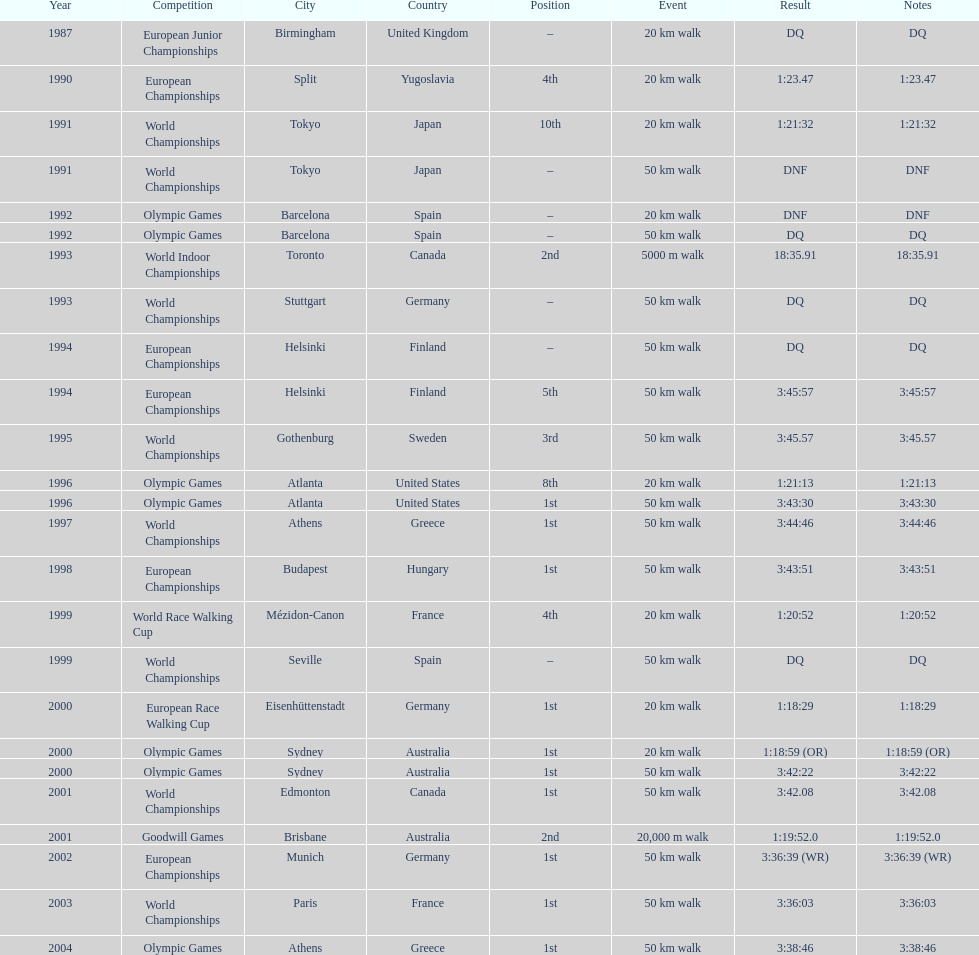How many times did korzeniowski finish above fourth place? 13. I'm looking to parse the entire table for insights. Could you assist me with that? {'header': ['Year', 'Competition', 'City', 'Country', 'Position', 'Event', 'Result', 'Notes'], 'rows': [['1987', 'European Junior Championships', 'Birmingham', 'United Kingdom', '–', '20\xa0km walk', 'DQ', 'DQ'], ['1990', 'European Championships', 'Split', 'Yugoslavia', '4th', '20\xa0km walk', '1:23.47', '1:23.47'], ['1991', 'World Championships', 'Tokyo', 'Japan', '10th', '20\xa0km walk', '1:21:32', '1:21:32'], ['1991', 'World Championships', 'Tokyo', 'Japan', '–', '50\xa0km walk', 'DNF', 'DNF'], ['1992', 'Olympic Games', 'Barcelona', 'Spain', '–', '20\xa0km walk', 'DNF', 'DNF'], ['1992', 'Olympic Games', 'Barcelona', 'Spain', '–', '50\xa0km walk', 'DQ', 'DQ'], ['1993', 'World Indoor Championships', 'Toronto', 'Canada', '2nd', '5000 m walk', '18:35.91', '18:35.91'], ['1993', 'World Championships', 'Stuttgart', 'Germany', '–', '50\xa0km walk', 'DQ', 'DQ'], ['1994', 'European Championships', 'Helsinki', 'Finland', '–', '50\xa0km walk', 'DQ', 'DQ'], ['1994', 'European Championships', 'Helsinki', 'Finland', '5th', '50\xa0km walk', '3:45:57', '3:45:57'], ['1995', 'World Championships', 'Gothenburg', 'Sweden', '3rd', '50\xa0km walk', '3:45.57', '3:45.57'], ['1996', 'Olympic Games', 'Atlanta', 'United States', '8th', '20\xa0km walk', '1:21:13', '1:21:13'], ['1996', 'Olympic Games', 'Atlanta', 'United States', '1st', '50\xa0km walk', '3:43:30', '3:43:30'], ['1997', 'World Championships', 'Athens', 'Greece', '1st', '50\xa0km walk', '3:44:46', '3:44:46'], ['1998', 'European Championships', 'Budapest', 'Hungary', '1st', '50\xa0km walk', '3:43:51', '3:43:51'], ['1999', 'World Race Walking Cup', 'Mézidon-Canon', 'France', '4th', '20\xa0km walk', '1:20:52', '1:20:52'], ['1999', 'World Championships', 'Seville', 'Spain', '–', '50\xa0km walk', 'DQ', 'DQ'], ['2000', 'European Race Walking Cup', 'Eisenhüttenstadt', 'Germany', '1st', '20\xa0km walk', '1:18:29', '1:18:29'], ['2000', 'Olympic Games', 'Sydney', 'Australia', '1st', '20\xa0km walk', '1:18:59 (OR)', '1:18:59 (OR)'], ['2000', 'Olympic Games', 'Sydney', 'Australia', '1st', '50\xa0km walk', '3:42:22', '3:42:22'], ['2001', 'World Championships', 'Edmonton', 'Canada', '1st', '50\xa0km walk', '3:42.08', '3:42.08'], ['2001', 'Goodwill Games', 'Brisbane', 'Australia', '2nd', '20,000 m walk', '1:19:52.0', '1:19:52.0'], ['2002', 'European Championships', 'Munich', 'Germany', '1st', '50\xa0km walk', '3:36:39 (WR)', '3:36:39 (WR)'], ['2003', 'World Championships', 'Paris', 'France', '1st', '50\xa0km walk', '3:36:03', '3:36:03'], ['2004', 'Olympic Games', 'Athens', 'Greece', '1st', '50\xa0km walk', '3:38:46', '3:38:46']]} 